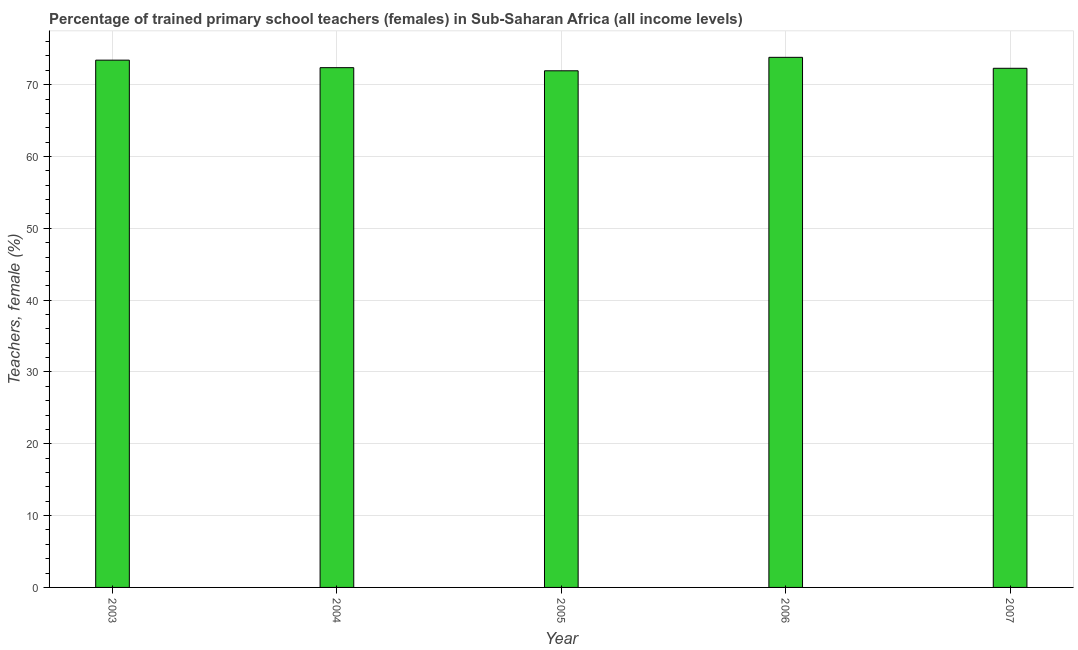Does the graph contain grids?
Offer a very short reply. Yes. What is the title of the graph?
Provide a short and direct response. Percentage of trained primary school teachers (females) in Sub-Saharan Africa (all income levels). What is the label or title of the Y-axis?
Provide a succinct answer. Teachers, female (%). What is the percentage of trained female teachers in 2006?
Your answer should be very brief. 73.81. Across all years, what is the maximum percentage of trained female teachers?
Provide a succinct answer. 73.81. Across all years, what is the minimum percentage of trained female teachers?
Provide a succinct answer. 71.93. In which year was the percentage of trained female teachers maximum?
Ensure brevity in your answer.  2006. What is the sum of the percentage of trained female teachers?
Your response must be concise. 363.8. What is the difference between the percentage of trained female teachers in 2003 and 2007?
Provide a short and direct response. 1.13. What is the average percentage of trained female teachers per year?
Make the answer very short. 72.76. What is the median percentage of trained female teachers?
Make the answer very short. 72.37. Do a majority of the years between 2006 and 2004 (inclusive) have percentage of trained female teachers greater than 48 %?
Keep it short and to the point. Yes. What is the ratio of the percentage of trained female teachers in 2003 to that in 2005?
Your answer should be very brief. 1.02. Is the percentage of trained female teachers in 2004 less than that in 2005?
Offer a terse response. No. Is the difference between the percentage of trained female teachers in 2005 and 2007 greater than the difference between any two years?
Provide a succinct answer. No. What is the difference between the highest and the second highest percentage of trained female teachers?
Ensure brevity in your answer.  0.39. What is the difference between the highest and the lowest percentage of trained female teachers?
Your answer should be compact. 1.87. Are all the bars in the graph horizontal?
Make the answer very short. No. What is the Teachers, female (%) in 2003?
Make the answer very short. 73.41. What is the Teachers, female (%) of 2004?
Your answer should be very brief. 72.37. What is the Teachers, female (%) of 2005?
Offer a very short reply. 71.93. What is the Teachers, female (%) in 2006?
Ensure brevity in your answer.  73.81. What is the Teachers, female (%) of 2007?
Your answer should be compact. 72.28. What is the difference between the Teachers, female (%) in 2003 and 2004?
Provide a short and direct response. 1.05. What is the difference between the Teachers, female (%) in 2003 and 2005?
Your answer should be very brief. 1.48. What is the difference between the Teachers, female (%) in 2003 and 2006?
Your response must be concise. -0.39. What is the difference between the Teachers, female (%) in 2003 and 2007?
Keep it short and to the point. 1.13. What is the difference between the Teachers, female (%) in 2004 and 2005?
Offer a very short reply. 0.43. What is the difference between the Teachers, female (%) in 2004 and 2006?
Provide a short and direct response. -1.44. What is the difference between the Teachers, female (%) in 2004 and 2007?
Ensure brevity in your answer.  0.09. What is the difference between the Teachers, female (%) in 2005 and 2006?
Your answer should be compact. -1.87. What is the difference between the Teachers, female (%) in 2005 and 2007?
Offer a very short reply. -0.35. What is the difference between the Teachers, female (%) in 2006 and 2007?
Your answer should be compact. 1.53. What is the ratio of the Teachers, female (%) in 2003 to that in 2004?
Offer a very short reply. 1.01. What is the ratio of the Teachers, female (%) in 2003 to that in 2005?
Your response must be concise. 1.02. What is the ratio of the Teachers, female (%) in 2003 to that in 2007?
Offer a terse response. 1.02. What is the ratio of the Teachers, female (%) in 2004 to that in 2005?
Your answer should be compact. 1.01. What is the ratio of the Teachers, female (%) in 2005 to that in 2006?
Offer a very short reply. 0.97. What is the ratio of the Teachers, female (%) in 2005 to that in 2007?
Give a very brief answer. 0.99. 